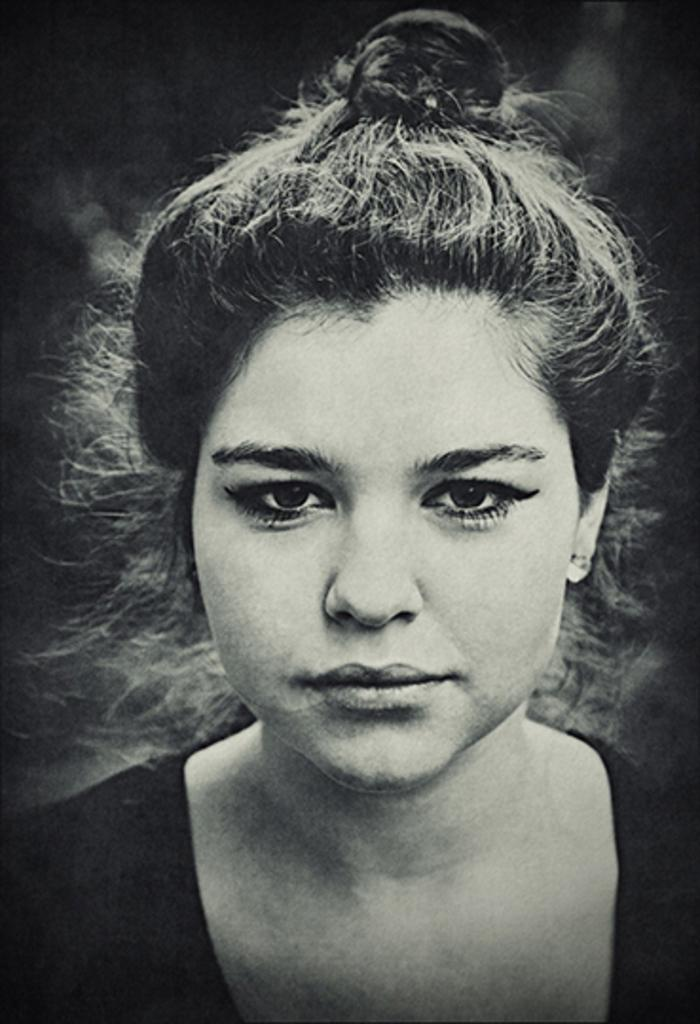What is the main subject of the image? There is a photo of a woman in the image. What word does the fireman use to describe the pleasure he feels while rescuing people? There is no fireman or any indication of pleasure or words in the image, as it only features a photo of a woman. 